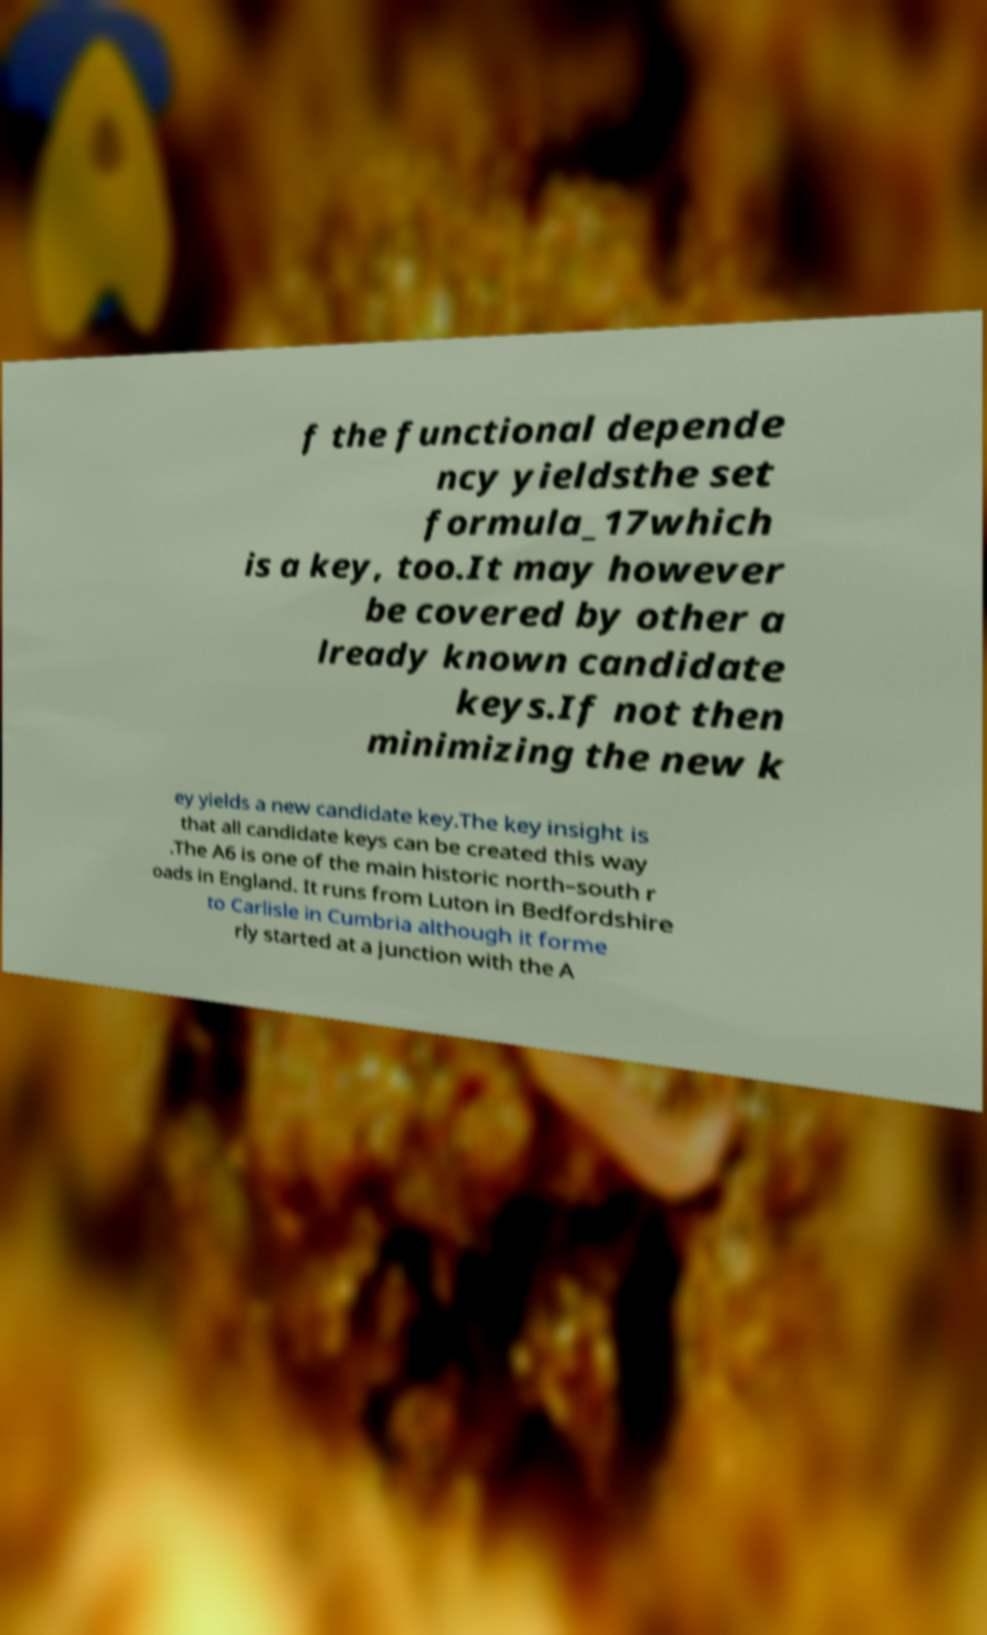Please identify and transcribe the text found in this image. f the functional depende ncy yieldsthe set formula_17which is a key, too.It may however be covered by other a lready known candidate keys.If not then minimizing the new k ey yields a new candidate key.The key insight is that all candidate keys can be created this way .The A6 is one of the main historic north–south r oads in England. It runs from Luton in Bedfordshire to Carlisle in Cumbria although it forme rly started at a junction with the A 